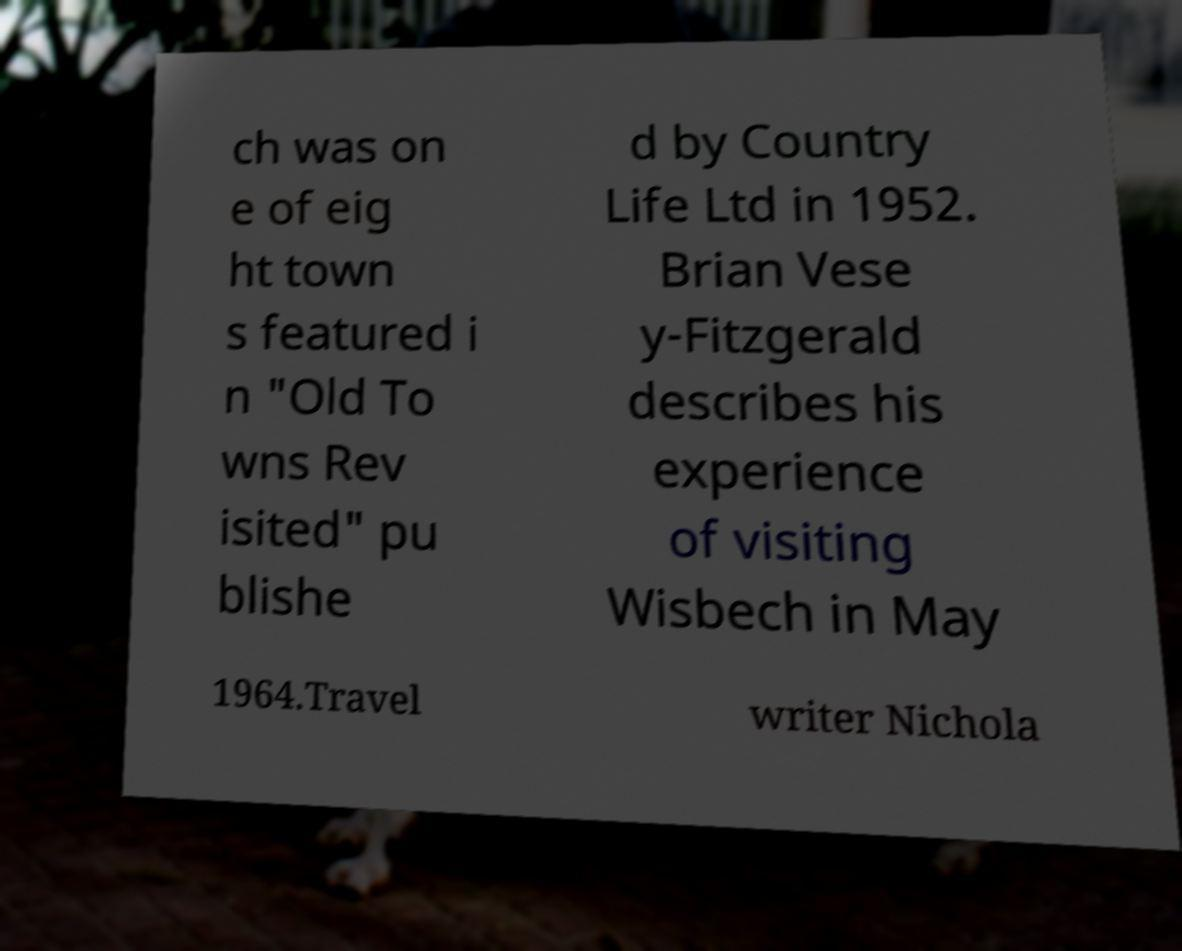Could you assist in decoding the text presented in this image and type it out clearly? ch was on e of eig ht town s featured i n "Old To wns Rev isited" pu blishe d by Country Life Ltd in 1952. Brian Vese y-Fitzgerald describes his experience of visiting Wisbech in May 1964.Travel writer Nichola 